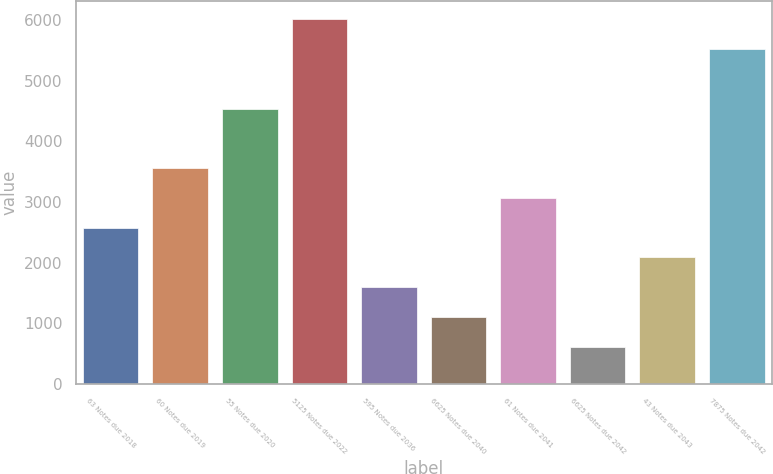<chart> <loc_0><loc_0><loc_500><loc_500><bar_chart><fcel>63 Notes due 2018<fcel>60 Notes due 2019<fcel>55 Notes due 2020<fcel>5125 Notes due 2022<fcel>595 Notes due 2036<fcel>6625 Notes due 2040<fcel>61 Notes due 2041<fcel>6625 Notes due 2042<fcel>43 Notes due 2043<fcel>7875 Notes due 2042<nl><fcel>2576.5<fcel>3558.3<fcel>4540.1<fcel>6012.8<fcel>1594.7<fcel>1103.8<fcel>3067.4<fcel>612.9<fcel>2085.6<fcel>5521.9<nl></chart> 